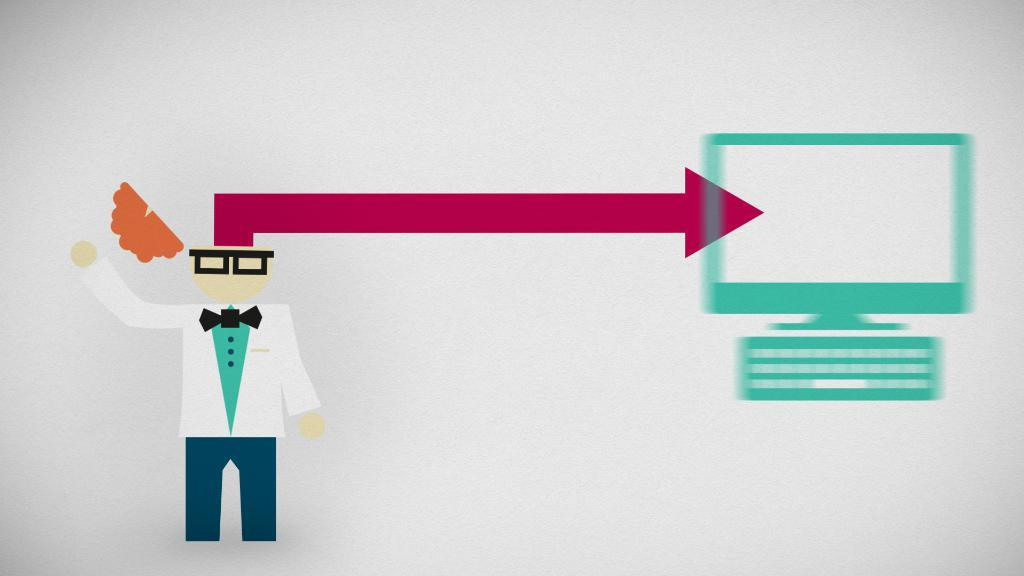Who or what is present in the image? There is a person in the image. What electronic device can be seen in the image? There is a monitor in the image. What is the person likely using with the monitor? There is a keyboard in the image, which suggests the person is using it with the monitor. What type of cable is being used to connect the stone and zinc in the image? There is no stone, zinc, or cable present in the image. 